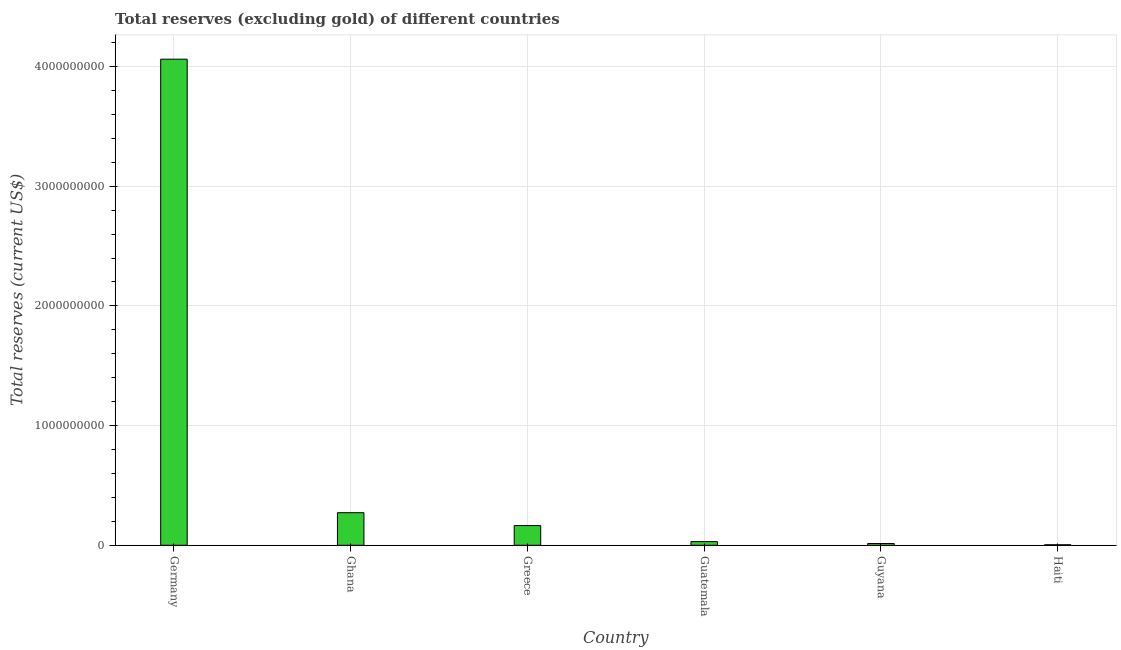What is the title of the graph?
Your answer should be very brief. Total reserves (excluding gold) of different countries. What is the label or title of the Y-axis?
Offer a terse response. Total reserves (current US$). What is the total reserves (excluding gold) in Ghana?
Offer a very short reply. 2.72e+08. Across all countries, what is the maximum total reserves (excluding gold)?
Your response must be concise. 4.06e+09. Across all countries, what is the minimum total reserves (excluding gold)?
Give a very brief answer. 4.30e+06. In which country was the total reserves (excluding gold) minimum?
Offer a very short reply. Haiti. What is the sum of the total reserves (excluding gold)?
Your answer should be very brief. 4.55e+09. What is the difference between the total reserves (excluding gold) in Guyana and Haiti?
Your response must be concise. 1.04e+07. What is the average total reserves (excluding gold) per country?
Ensure brevity in your answer.  7.58e+08. What is the median total reserves (excluding gold)?
Provide a short and direct response. 9.75e+07. In how many countries, is the total reserves (excluding gold) greater than 1800000000 US$?
Your response must be concise. 1. What is the ratio of the total reserves (excluding gold) in Germany to that in Guyana?
Offer a terse response. 275.55. What is the difference between the highest and the second highest total reserves (excluding gold)?
Your response must be concise. 3.79e+09. Is the sum of the total reserves (excluding gold) in Germany and Ghana greater than the maximum total reserves (excluding gold) across all countries?
Offer a terse response. Yes. What is the difference between the highest and the lowest total reserves (excluding gold)?
Provide a short and direct response. 4.06e+09. How many bars are there?
Your answer should be very brief. 6. Are all the bars in the graph horizontal?
Ensure brevity in your answer.  No. How many countries are there in the graph?
Your response must be concise. 6. What is the difference between two consecutive major ticks on the Y-axis?
Provide a short and direct response. 1.00e+09. What is the Total reserves (current US$) of Germany?
Give a very brief answer. 4.06e+09. What is the Total reserves (current US$) in Ghana?
Provide a succinct answer. 2.72e+08. What is the Total reserves (current US$) in Greece?
Offer a very short reply. 1.65e+08. What is the Total reserves (current US$) in Guatemala?
Ensure brevity in your answer.  3.05e+07. What is the Total reserves (current US$) of Guyana?
Ensure brevity in your answer.  1.47e+07. What is the Total reserves (current US$) of Haiti?
Provide a succinct answer. 4.30e+06. What is the difference between the Total reserves (current US$) in Germany and Ghana?
Your answer should be compact. 3.79e+09. What is the difference between the Total reserves (current US$) in Germany and Greece?
Keep it short and to the point. 3.90e+09. What is the difference between the Total reserves (current US$) in Germany and Guatemala?
Your response must be concise. 4.03e+09. What is the difference between the Total reserves (current US$) in Germany and Guyana?
Offer a very short reply. 4.05e+09. What is the difference between the Total reserves (current US$) in Germany and Haiti?
Provide a succinct answer. 4.06e+09. What is the difference between the Total reserves (current US$) in Ghana and Greece?
Your answer should be very brief. 1.08e+08. What is the difference between the Total reserves (current US$) in Ghana and Guatemala?
Your answer should be very brief. 2.42e+08. What is the difference between the Total reserves (current US$) in Ghana and Guyana?
Provide a succinct answer. 2.57e+08. What is the difference between the Total reserves (current US$) in Ghana and Haiti?
Give a very brief answer. 2.68e+08. What is the difference between the Total reserves (current US$) in Greece and Guatemala?
Ensure brevity in your answer.  1.34e+08. What is the difference between the Total reserves (current US$) in Greece and Guyana?
Provide a short and direct response. 1.50e+08. What is the difference between the Total reserves (current US$) in Greece and Haiti?
Your answer should be very brief. 1.60e+08. What is the difference between the Total reserves (current US$) in Guatemala and Guyana?
Provide a short and direct response. 1.57e+07. What is the difference between the Total reserves (current US$) in Guatemala and Haiti?
Your answer should be very brief. 2.62e+07. What is the difference between the Total reserves (current US$) in Guyana and Haiti?
Ensure brevity in your answer.  1.04e+07. What is the ratio of the Total reserves (current US$) in Germany to that in Ghana?
Your response must be concise. 14.92. What is the ratio of the Total reserves (current US$) in Germany to that in Greece?
Keep it short and to the point. 24.68. What is the ratio of the Total reserves (current US$) in Germany to that in Guatemala?
Offer a terse response. 133.34. What is the ratio of the Total reserves (current US$) in Germany to that in Guyana?
Offer a terse response. 275.55. What is the ratio of the Total reserves (current US$) in Germany to that in Haiti?
Provide a short and direct response. 944.57. What is the ratio of the Total reserves (current US$) in Ghana to that in Greece?
Give a very brief answer. 1.65. What is the ratio of the Total reserves (current US$) in Ghana to that in Guatemala?
Offer a terse response. 8.94. What is the ratio of the Total reserves (current US$) in Ghana to that in Guyana?
Offer a terse response. 18.47. What is the ratio of the Total reserves (current US$) in Ghana to that in Haiti?
Ensure brevity in your answer.  63.31. What is the ratio of the Total reserves (current US$) in Greece to that in Guatemala?
Your response must be concise. 5.4. What is the ratio of the Total reserves (current US$) in Greece to that in Guyana?
Your answer should be very brief. 11.17. What is the ratio of the Total reserves (current US$) in Greece to that in Haiti?
Your answer should be compact. 38.28. What is the ratio of the Total reserves (current US$) in Guatemala to that in Guyana?
Your answer should be compact. 2.07. What is the ratio of the Total reserves (current US$) in Guatemala to that in Haiti?
Provide a short and direct response. 7.08. What is the ratio of the Total reserves (current US$) in Guyana to that in Haiti?
Offer a very short reply. 3.43. 